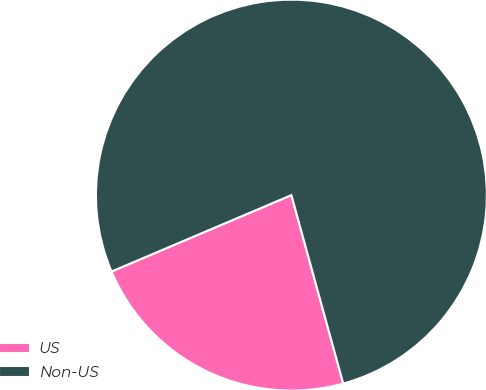Convert chart. <chart><loc_0><loc_0><loc_500><loc_500><pie_chart><fcel>US<fcel>Non-US<nl><fcel>22.88%<fcel>77.12%<nl></chart> 